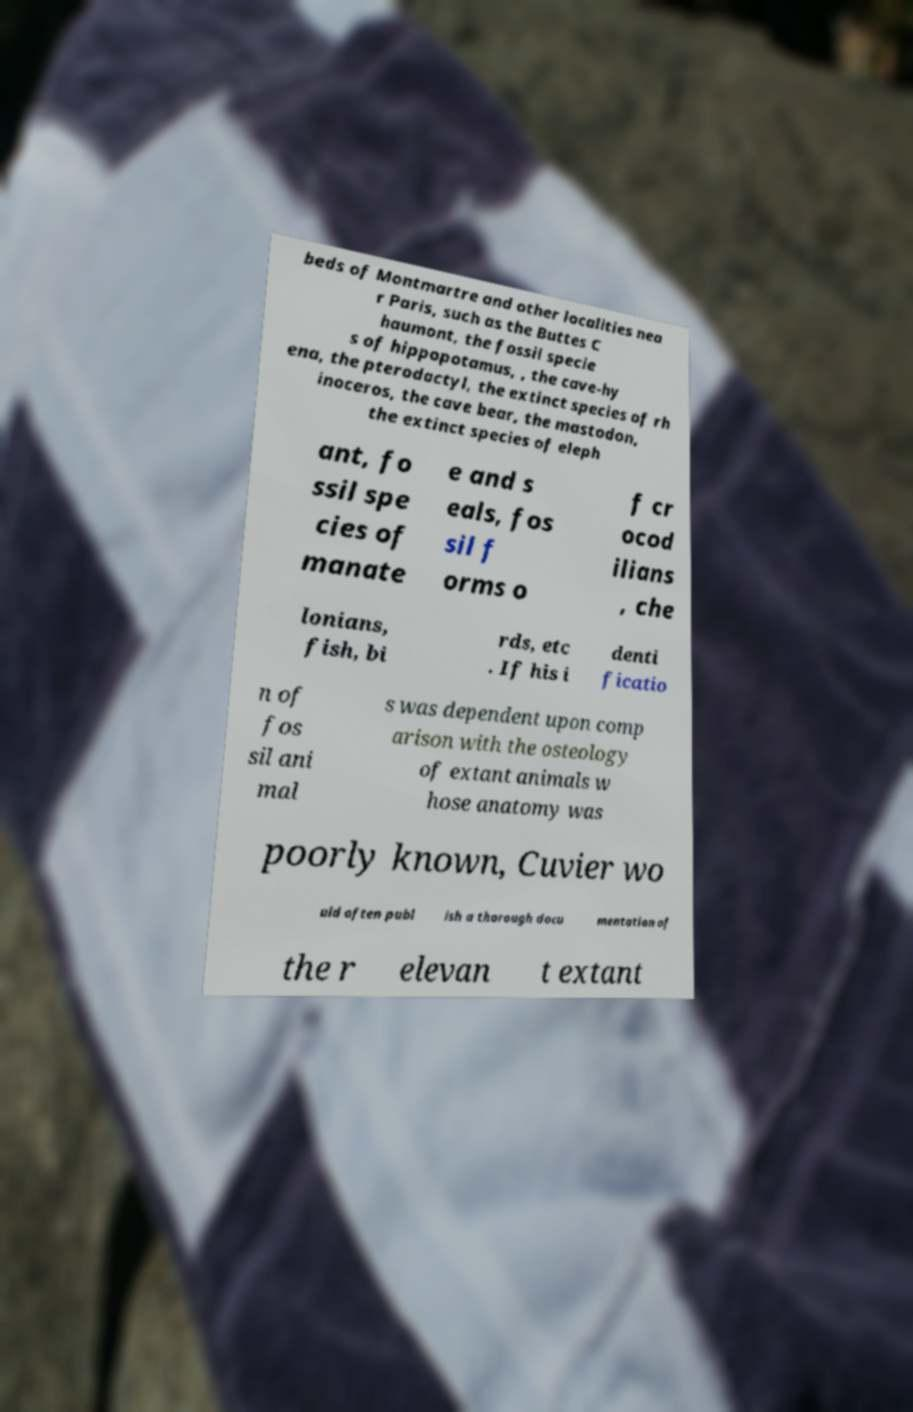Please identify and transcribe the text found in this image. beds of Montmartre and other localities nea r Paris, such as the Buttes C haumont, the fossil specie s of hippopotamus, , the cave-hy ena, the pterodactyl, the extinct species of rh inoceros, the cave bear, the mastodon, the extinct species of eleph ant, fo ssil spe cies of manate e and s eals, fos sil f orms o f cr ocod ilians , che lonians, fish, bi rds, etc . If his i denti ficatio n of fos sil ani mal s was dependent upon comp arison with the osteology of extant animals w hose anatomy was poorly known, Cuvier wo uld often publ ish a thorough docu mentation of the r elevan t extant 